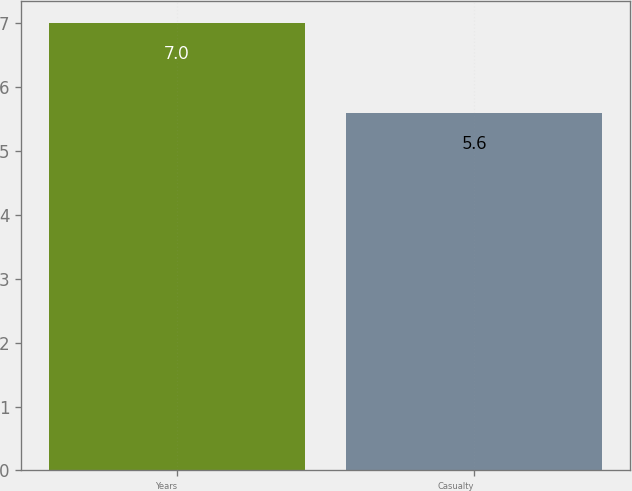<chart> <loc_0><loc_0><loc_500><loc_500><bar_chart><fcel>Years<fcel>Casualty<nl><fcel>7<fcel>5.6<nl></chart> 